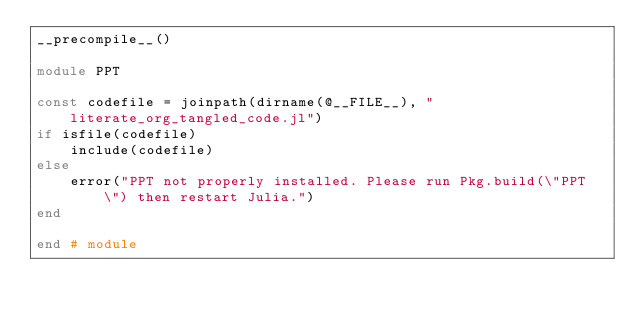<code> <loc_0><loc_0><loc_500><loc_500><_Julia_>__precompile__()

module PPT

const codefile = joinpath(dirname(@__FILE__), "literate_org_tangled_code.jl")
if isfile(codefile)
    include(codefile)
else
    error("PPT not properly installed. Please run Pkg.build(\"PPT\") then restart Julia.")
end

end # module
</code> 